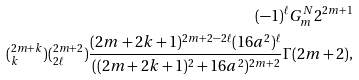<formula> <loc_0><loc_0><loc_500><loc_500>( - 1 ) ^ { \ell } G _ { m } ^ { N } 2 ^ { 2 m + 1 } \\ ( _ { k } ^ { 2 m + k } ) ( _ { 2 \ell } ^ { 2 m + 2 } ) \frac { ( 2 m + 2 k + 1 ) ^ { 2 m + 2 - 2 \ell } ( 1 6 a ^ { 2 } ) ^ { \ell } } { ( ( 2 m + 2 k + 1 ) ^ { 2 } + 1 6 a ^ { 2 } ) ^ { 2 m + 2 } } \Gamma ( 2 m + 2 ) ,</formula> 